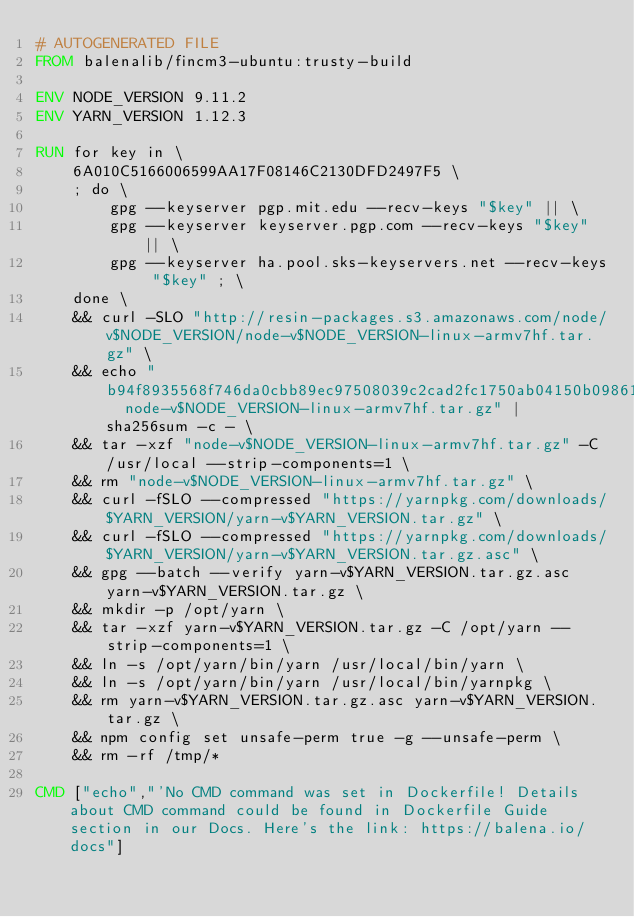<code> <loc_0><loc_0><loc_500><loc_500><_Dockerfile_># AUTOGENERATED FILE
FROM balenalib/fincm3-ubuntu:trusty-build

ENV NODE_VERSION 9.11.2
ENV YARN_VERSION 1.12.3

RUN for key in \
	6A010C5166006599AA17F08146C2130DFD2497F5 \
	; do \
		gpg --keyserver pgp.mit.edu --recv-keys "$key" || \
		gpg --keyserver keyserver.pgp.com --recv-keys "$key" || \
		gpg --keyserver ha.pool.sks-keyservers.net --recv-keys "$key" ; \
	done \
	&& curl -SLO "http://resin-packages.s3.amazonaws.com/node/v$NODE_VERSION/node-v$NODE_VERSION-linux-armv7hf.tar.gz" \
	&& echo "b94f8935568f746da0cbb89ec97508039c2cad2fc1750ab04150b098614b9241  node-v$NODE_VERSION-linux-armv7hf.tar.gz" | sha256sum -c - \
	&& tar -xzf "node-v$NODE_VERSION-linux-armv7hf.tar.gz" -C /usr/local --strip-components=1 \
	&& rm "node-v$NODE_VERSION-linux-armv7hf.tar.gz" \
	&& curl -fSLO --compressed "https://yarnpkg.com/downloads/$YARN_VERSION/yarn-v$YARN_VERSION.tar.gz" \
	&& curl -fSLO --compressed "https://yarnpkg.com/downloads/$YARN_VERSION/yarn-v$YARN_VERSION.tar.gz.asc" \
	&& gpg --batch --verify yarn-v$YARN_VERSION.tar.gz.asc yarn-v$YARN_VERSION.tar.gz \
	&& mkdir -p /opt/yarn \
	&& tar -xzf yarn-v$YARN_VERSION.tar.gz -C /opt/yarn --strip-components=1 \
	&& ln -s /opt/yarn/bin/yarn /usr/local/bin/yarn \
	&& ln -s /opt/yarn/bin/yarn /usr/local/bin/yarnpkg \
	&& rm yarn-v$YARN_VERSION.tar.gz.asc yarn-v$YARN_VERSION.tar.gz \
	&& npm config set unsafe-perm true -g --unsafe-perm \
	&& rm -rf /tmp/*

CMD ["echo","'No CMD command was set in Dockerfile! Details about CMD command could be found in Dockerfile Guide section in our Docs. Here's the link: https://balena.io/docs"]</code> 